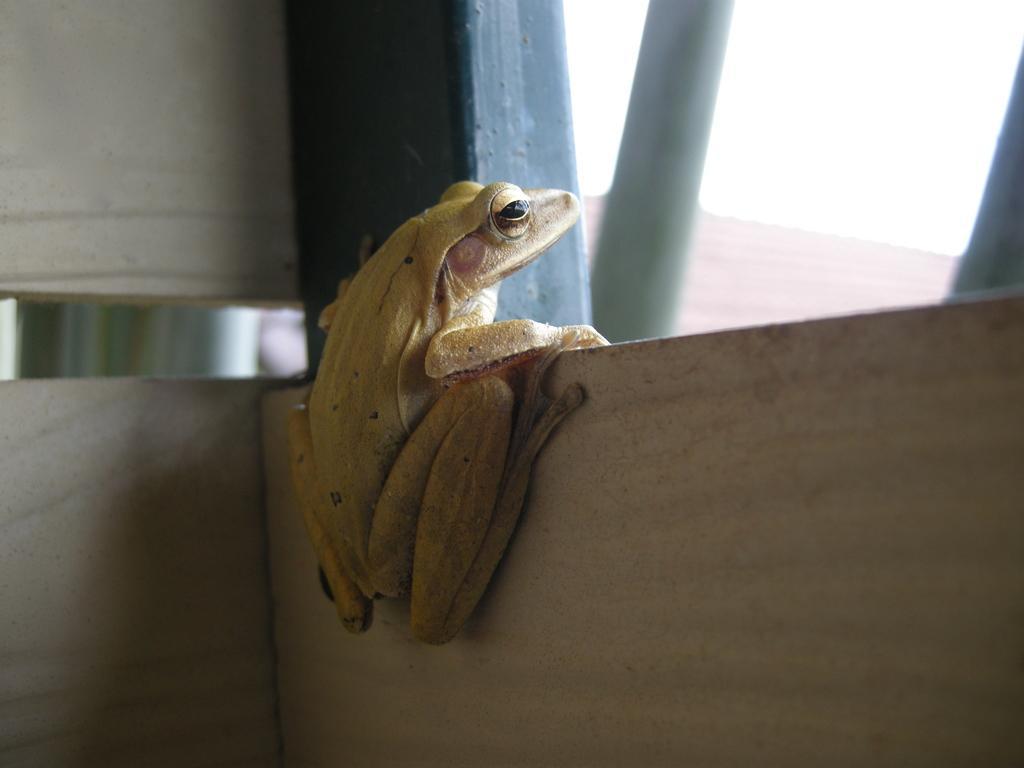In one or two sentences, can you explain what this image depicts? In this picture we can observe a frog on the wall and this is rod. On the background we can see a roof here, and this is sky. 